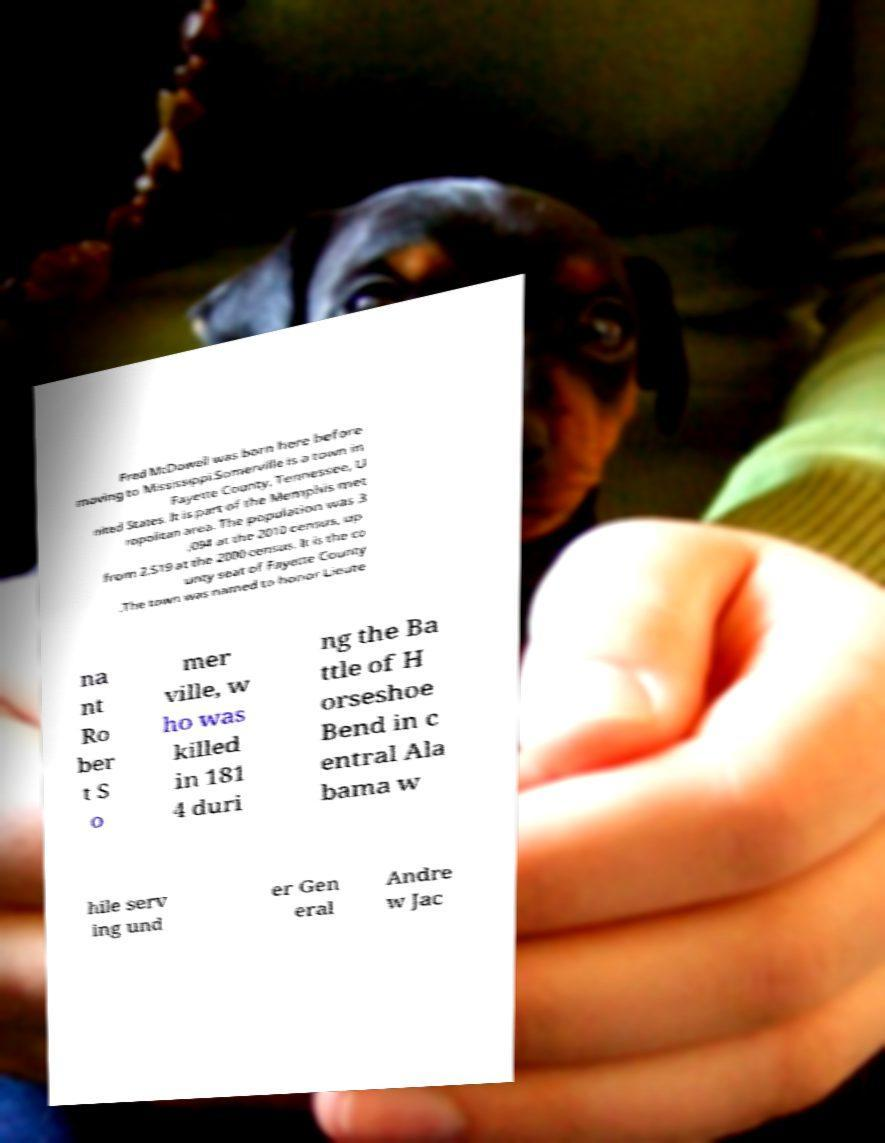Please read and relay the text visible in this image. What does it say? Fred McDowell was born here before moving to Mississippi.Somerville is a town in Fayette County, Tennessee, U nited States. It is part of the Memphis met ropolitan area. The population was 3 ,094 at the 2010 census, up from 2,519 at the 2000 census. It is the co unty seat of Fayette County .The town was named to honor Lieute na nt Ro ber t S o mer ville, w ho was killed in 181 4 duri ng the Ba ttle of H orseshoe Bend in c entral Ala bama w hile serv ing und er Gen eral Andre w Jac 